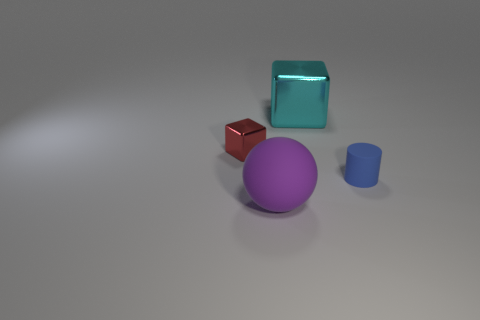Add 1 red objects. How many objects exist? 5 Subtract all cylinders. How many objects are left? 3 Subtract all tiny shiny cubes. Subtract all red cubes. How many objects are left? 2 Add 1 tiny red things. How many tiny red things are left? 2 Add 2 big rubber balls. How many big rubber balls exist? 3 Subtract 0 brown spheres. How many objects are left? 4 